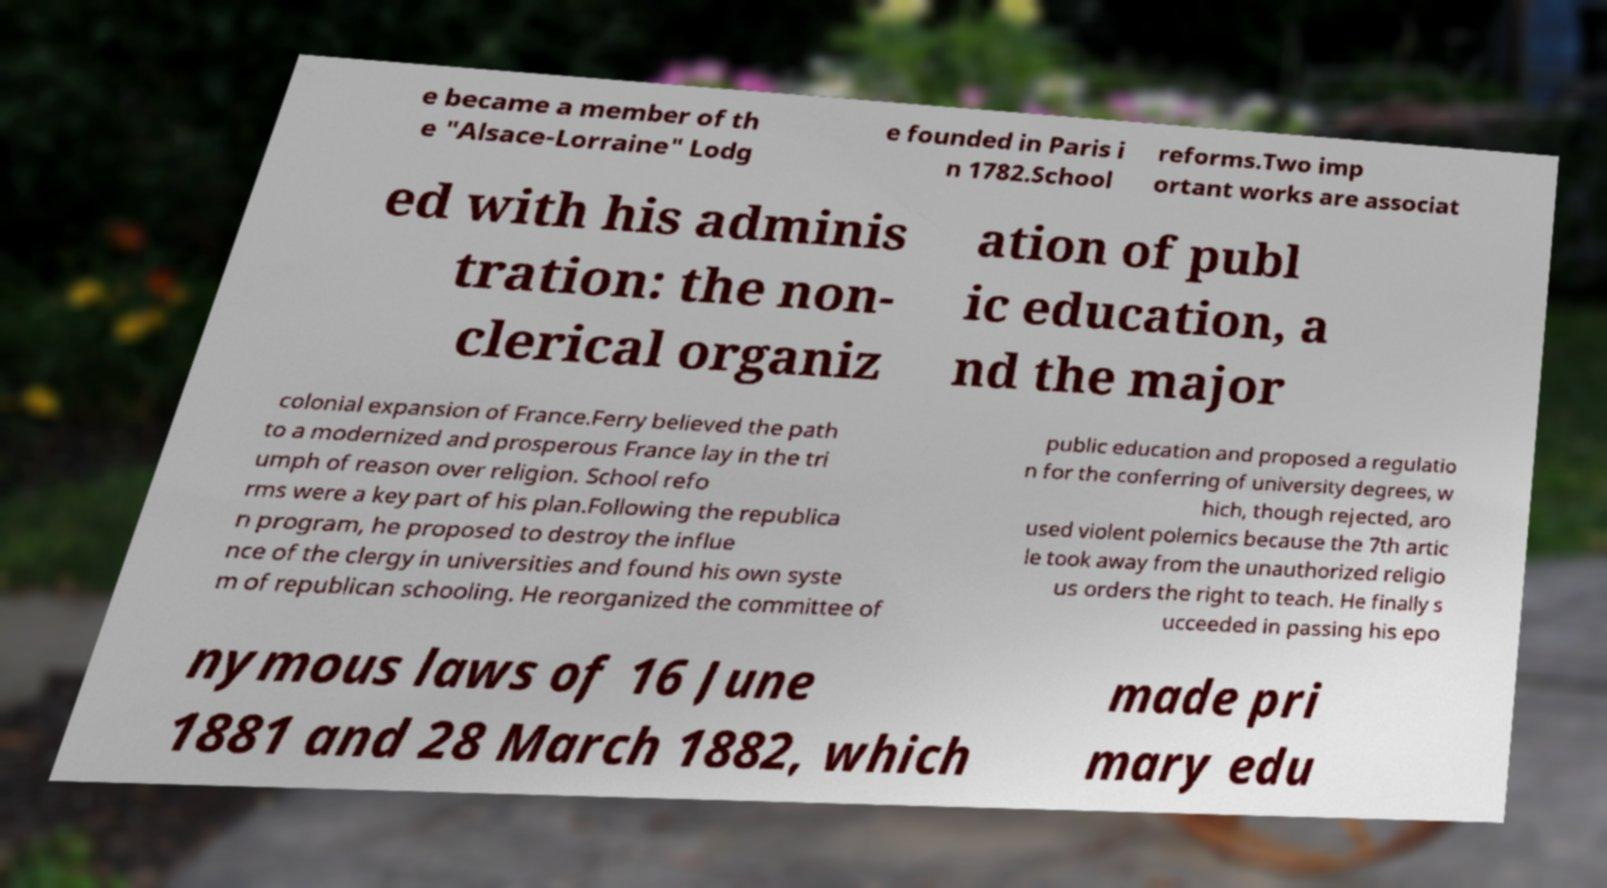Can you accurately transcribe the text from the provided image for me? e became a member of th e "Alsace-Lorraine" Lodg e founded in Paris i n 1782.School reforms.Two imp ortant works are associat ed with his adminis tration: the non- clerical organiz ation of publ ic education, a nd the major colonial expansion of France.Ferry believed the path to a modernized and prosperous France lay in the tri umph of reason over religion. School refo rms were a key part of his plan.Following the republica n program, he proposed to destroy the influe nce of the clergy in universities and found his own syste m of republican schooling. He reorganized the committee of public education and proposed a regulatio n for the conferring of university degrees, w hich, though rejected, aro used violent polemics because the 7th artic le took away from the unauthorized religio us orders the right to teach. He finally s ucceeded in passing his epo nymous laws of 16 June 1881 and 28 March 1882, which made pri mary edu 